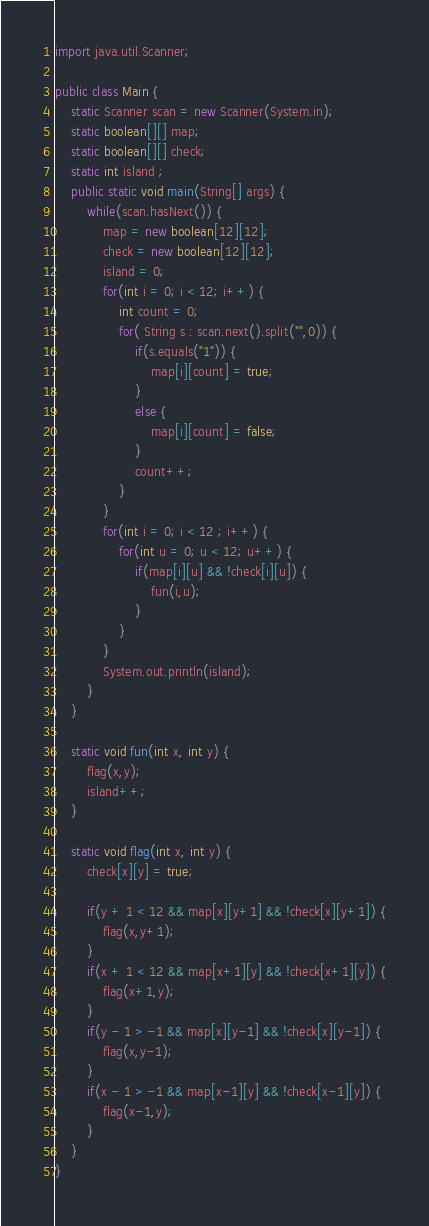Convert code to text. <code><loc_0><loc_0><loc_500><loc_500><_Java_>import java.util.Scanner;

public class Main {
	static Scanner scan = new Scanner(System.in);
	static boolean[][] map;
	static boolean[][] check;
	static int island ;
	public static void main(String[] args) {
		while(scan.hasNext()) {
			map = new boolean[12][12];
			check = new boolean[12][12];
			island = 0;
			for(int i = 0; i < 12; i++) {
				int count = 0;
				for( String s : scan.next().split("",0)) {
					if(s.equals("1")) {
						map[i][count] = true;
					}
					else {
						map[i][count] = false;
					}
					count++;
				}
			}
			for(int i = 0; i < 12 ; i++) {
				for(int u = 0; u < 12; u++) {
					if(map[i][u] && !check[i][u]) {
						fun(i,u);
					}
				}
			}
			System.out.println(island);
		}
	}

	static void fun(int x, int y) {
		flag(x,y);
		island++;
	}

	static void flag(int x, int y) {
		check[x][y] = true;
	
		if(y + 1 < 12 && map[x][y+1] && !check[x][y+1]) {
			flag(x,y+1);
		}
		if(x + 1 < 12 && map[x+1][y] && !check[x+1][y]) {
			flag(x+1,y);
		}
		if(y - 1 > -1 && map[x][y-1] && !check[x][y-1]) {
			flag(x,y-1);
		}
		if(x - 1 > -1 && map[x-1][y] && !check[x-1][y]) {
			flag(x-1,y);
		} 			
	}
}</code> 